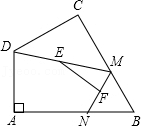What roles do points M, E, and F play in altering the lengths within the diagram? Points M, E, and F are crucial for adjusting segment lengths within the triangle DAB and influencing the resulting length of EF. Point M's placement along BC affects the shape and size of DM, consequently impacting point E, the midpoint of DM. Similarly, the position of point N on AB adjusts the length of MN and, therefore, affects point F, which is MN's midpoint. Thus, the placement of M and N dynamically changes the distances EF seeks to span, illustrating a direct correlation between these points and the length of EF. 